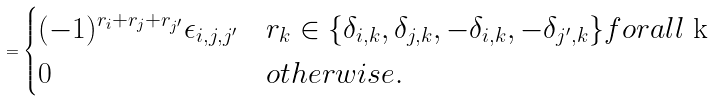Convert formula to latex. <formula><loc_0><loc_0><loc_500><loc_500>= \begin{cases} ( - 1 ) ^ { r _ { i } + r _ { j } + r _ { j ^ { \prime } } } \epsilon _ { i , j , j ^ { \prime } } & r _ { k } \in \{ \delta _ { i , k } , \delta _ { j , k } , - \delta _ { i , k } , - \delta _ { j ^ { \prime } , k } \} f o r a l l $ k $ \\ 0 & o t h e r w i s e . \end{cases}</formula> 